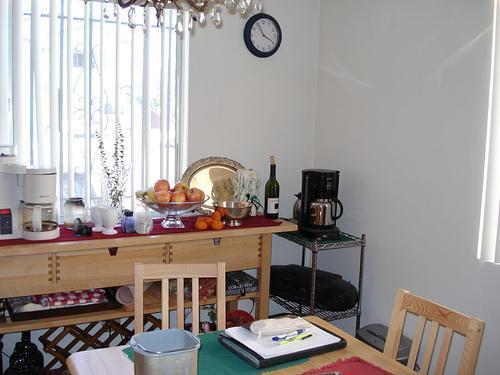How many coffeemakers are in this photo?
Give a very brief answer. 2. How many chairs are in the picture?
Give a very brief answer. 2. 